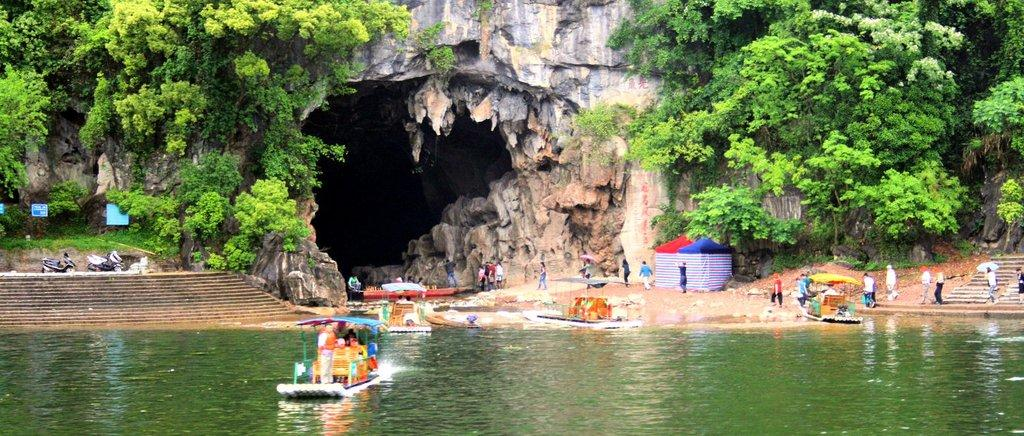What is the primary element visible in the image? There is water in the image. What types of vehicles can be seen in the image? There are boats in the image. What type of temporary shelter is present in the image? There are tents in the image. Can you describe any architectural features in the image? There are steps in the image. What other types of transportation are visible in the image? There are motorbikes in the image. What type of signage or markers can be seen in the image? There are boards in the image. What type of natural environment is present in the image? There is grass, trees, and plants in the image. What is the main geological feature in the middle of the image? There is a cave in the middle of the image. What are the people in the image using to protect themselves from the elements? There are people holding umbrellas in the image. How many sisters are present in the image? There is no mention of sisters in the image, so it cannot be determined from the facts provided. 